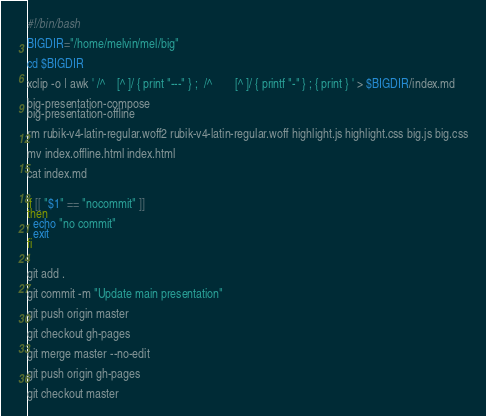<code> <loc_0><loc_0><loc_500><loc_500><_Bash_>#!/bin/bash

BIGDIR="/home/melvin/mel/big"

cd $BIGDIR

xclip -o | awk ' /^    [^ ]/ { print "---" } ;  /^        [^ ]/ { printf "-" } ; { print } ' > $BIGDIR/index.md

big-presentation-compose
big-presentation-offline

rm rubik-v4-latin-regular.woff2 rubik-v4-latin-regular.woff highlight.js highlight.css big.js big.css

mv index.offline.html index.html

cat index.md


if [[ "$1" == "nocommit" ]]
then
  echo "no commit"
  exit
fi


git add .

git commit -m "Update main presentation"

git push origin master

git checkout gh-pages

git merge master --no-edit

git push origin gh-pages

git checkout master
</code> 